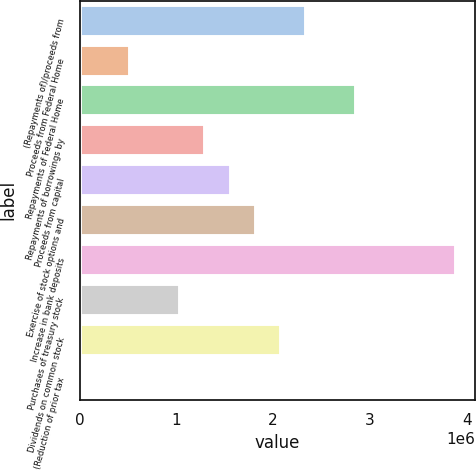Convert chart to OTSL. <chart><loc_0><loc_0><loc_500><loc_500><bar_chart><fcel>(Repayments of)/proceeds from<fcel>Proceeds from Federal Home<fcel>Repayments of Federal Home<fcel>Repayments of borrowings by<fcel>Proceeds from capital<fcel>Exercise of stock options and<fcel>Increase in bank deposits<fcel>Purchases of treasury stock<fcel>Dividends on common stock<fcel>(Reduction of prior tax<nl><fcel>2.33721e+06<fcel>521395<fcel>2.85602e+06<fcel>1.2996e+06<fcel>1.55901e+06<fcel>1.81841e+06<fcel>3.89363e+06<fcel>1.0402e+06<fcel>2.07781e+06<fcel>2590<nl></chart> 